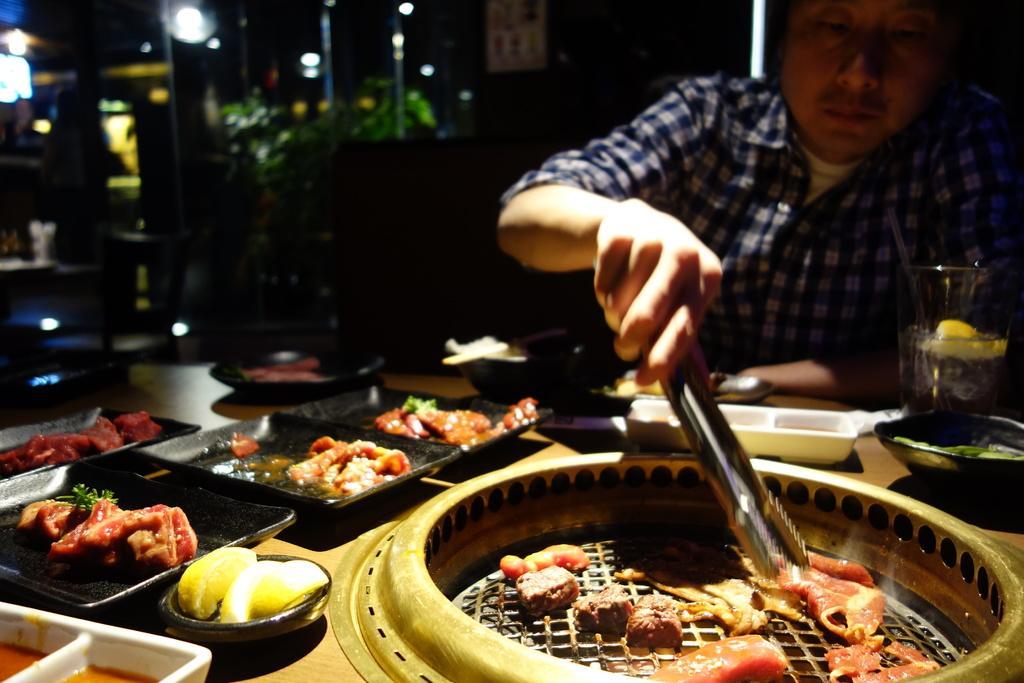Describe this image in one or two sentences. In this image we can see a person sitting and holding a spoon, before him there is a table and we can see plates, bowl, sauce, tray, meat, glass and some food placed on the table. In the background there are plants, poles and lights. 